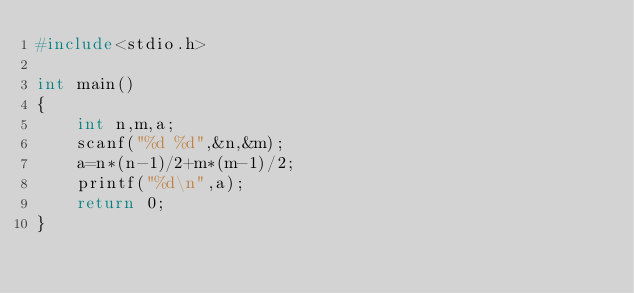Convert code to text. <code><loc_0><loc_0><loc_500><loc_500><_C_>#include<stdio.h>

int main()
{
    int n,m,a;
    scanf("%d %d",&n,&m);
    a=n*(n-1)/2+m*(m-1)/2;
    printf("%d\n",a);
    return 0;
}
</code> 